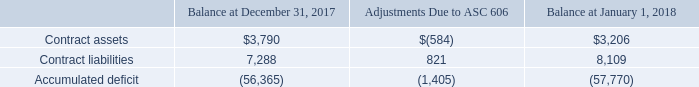3. REVENUE FROM CONTRACTS WITH CUSTOMERS
Revenues and related costs on construction contracts are recognized as the performance obligations are satisfied over time in accordance with ASC 606, Revenue from Contracts with Customers. Under ASC 606, revenue and associated profit, will be recognized as the customer obtains control of the goods and services promised in the contract (i.e., performance obligations). The cost of uninstalled materials or equipment will generally be excluded from the Company’s recognition of profit, unless specifically produced or manufactured for a project, because such costs are not considered to be a measure of progress.
In adopting ASC 606, the Company had the following significant changes in accounting principles:
(i) Timing of revenue recognition for uninstalled materials - The Company previously recognized the majority of its revenue from the installation or construction of commercial & public works projects using the percentage-of-completion method of accounting, whereby revenue is recognized as the Company progresses on the contract. The percentage-of-completion for each project was determined on an actual cost-to-estimated final cost basis. Under ASC 606, revenue and associated profit, is recognized as the customer obtains control of the goods and services promised in the contract (i.e., performance obligations). The cost of uninstalled materials or equipment is generally excluded from the Company’s recognition of profit, unless specifically produced or manufactured for a project, because such costs are not considered to be a measure of progress.
(ii) Completed contracts - The Company previously recognized the majority of its revenue from the installation of residential projects using the completed contract method of accounting whereby revenue the Company recognized when the project is completed. Under, ASC 606, revenue is recognized as the customer obtains control of the goods and services promised in the contract (i.e., performance obligations).
Revenue recognition for other sales arrangements such as the sales of materials will remain materially consistent with prior treatment.
The adoption of the new revenue recognition standard resulted in a cumulative effect adjustment to retained earnings of approximately $1,405 as of January 1, 2018. The details of this adjustment are summarized below.
What are the two changes in accounting principles in adopting ASC 606? Timing of revenue recognition for uninstalled materials, completed contracts. How is revenue recognised under ASC 606? Revenue is recognized as the customer obtains control of the goods and services promised in the contract (i.e., performance obligations). What is the Contract assets balance at December 31, 2017?  $3,790. What is the percentage change in the contract liabilities after adjustments due to ASC606?
Answer scale should be: percent. 821/7,288
Answer: 11.27. What is the percentage change in the contract assets after adjustments due to ASC606?
Answer scale should be: percent. -584/3,790
Answer: -15.41. What is the percentage change in the accumulated deficit after the adjustment?
Answer scale should be: percent. -1,405/-56,365
Answer: 2.49. 